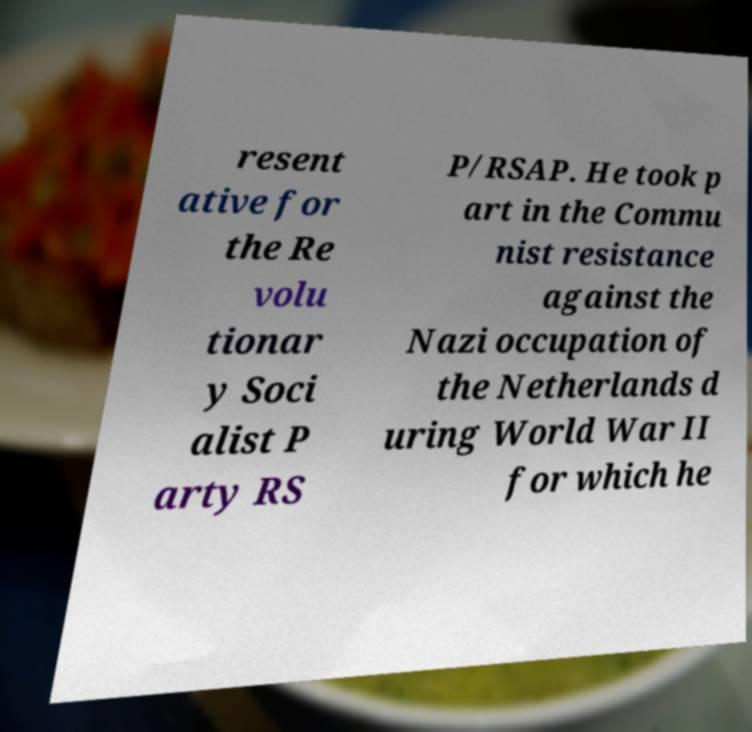Please read and relay the text visible in this image. What does it say? resent ative for the Re volu tionar y Soci alist P arty RS P/RSAP. He took p art in the Commu nist resistance against the Nazi occupation of the Netherlands d uring World War II for which he 